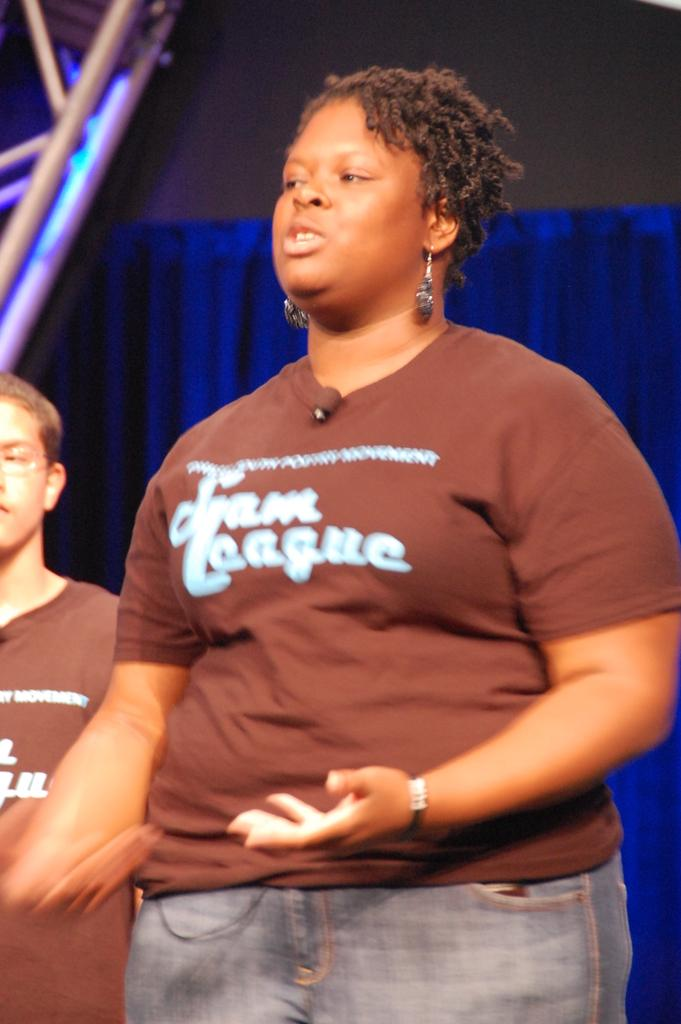How many people are in the image? There are two persons in the image. What are the two persons wearing? Both persons are wearing brown color shirts. What are the two persons doing in the image? The two persons are standing. What can be seen in the background of the image? There is a curtain and a lighting truss in the background of the image. How many ladybugs are crawling on the curtain in the image? There are no ladybugs present in the image; only the two persons, their clothing, and the background elements are visible. 